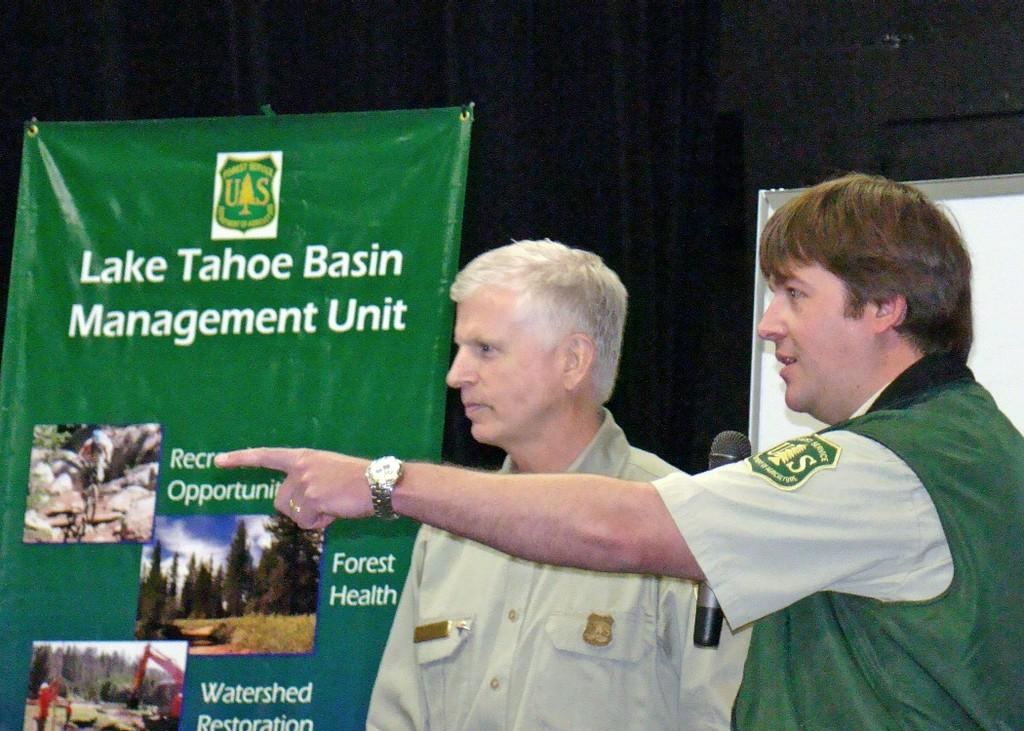How many people are in the image? There are two people standing in the image. Where are the people located in the image? The people are standing in the front. What else can be seen in the image besides the people? There are banners in the image. What is the man on the right side doing? The man on the right side is holding a mic. What type of key is the man holding in the image? There is no key present in the image; the man is holding a mic. Can you see a plate on the ground in the image? There is no plate visible in the image. 